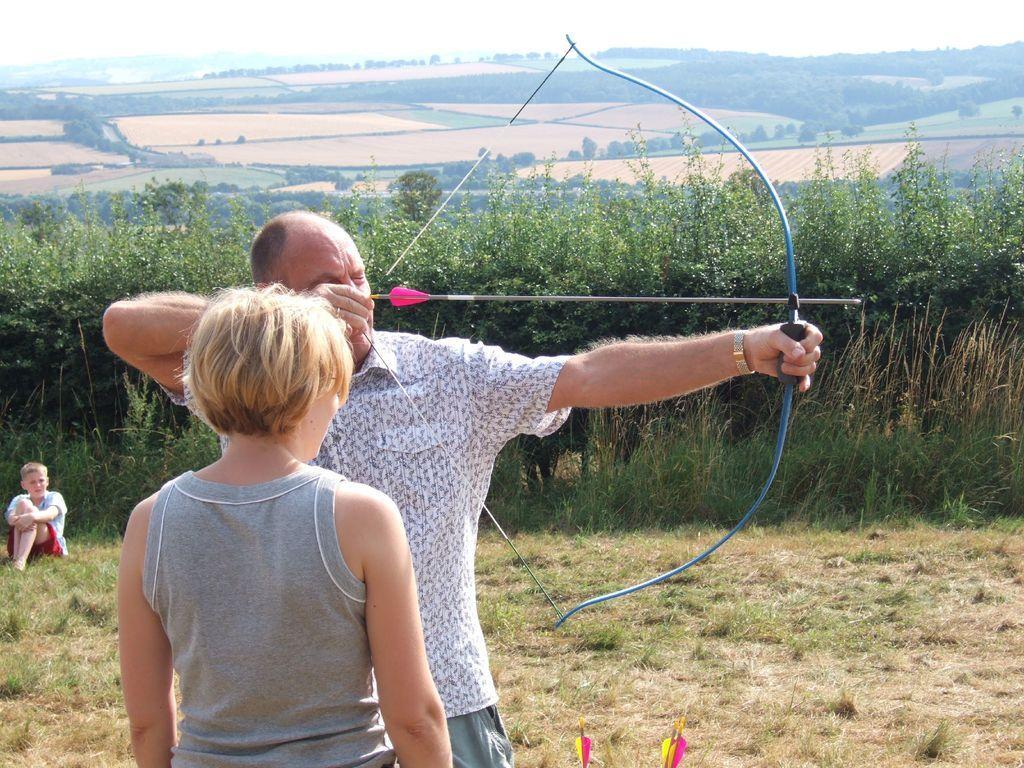Describe this image in one or two sentences. In this image we can see one person is holding an arrow and bow, beside that we can see two other people. And we can see grass, beside that we can see plants. And we can see open land, beside that we can see hills. And at the top we can see the sky. 